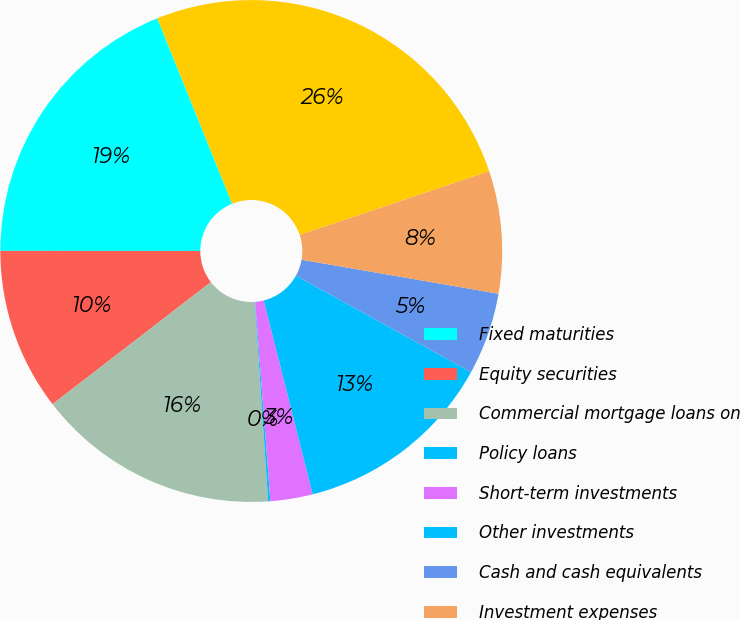Convert chart to OTSL. <chart><loc_0><loc_0><loc_500><loc_500><pie_chart><fcel>Fixed maturities<fcel>Equity securities<fcel>Commercial mortgage loans on<fcel>Policy loans<fcel>Short-term investments<fcel>Other investments<fcel>Cash and cash equivalents<fcel>Investment expenses<fcel>Net investment income<nl><fcel>18.88%<fcel>10.46%<fcel>15.62%<fcel>0.14%<fcel>2.72%<fcel>13.04%<fcel>5.3%<fcel>7.88%<fcel>25.95%<nl></chart> 